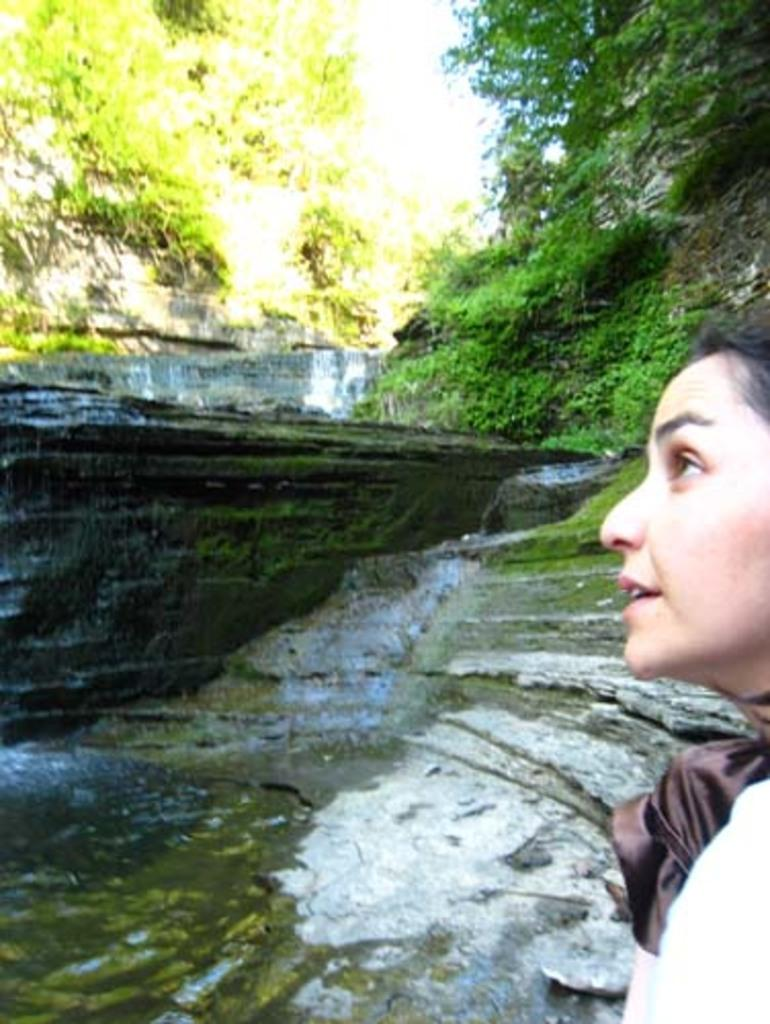Who is present on the right side of the image? There is a woman on the right side of the image. What can be seen on the left side of the image? There is water on the left side of the image. What is located in the middle of the image? There is a rock in the middle of the image. What type of vegetation is visible at the top of the image? Trees are visible at the top of the image. What type of flowers can be seen growing on the rock in the image? There are no flowers visible on the rock in the image. Can you tell me how many skateboards are present in the image? There are no skateboards present in the image. 